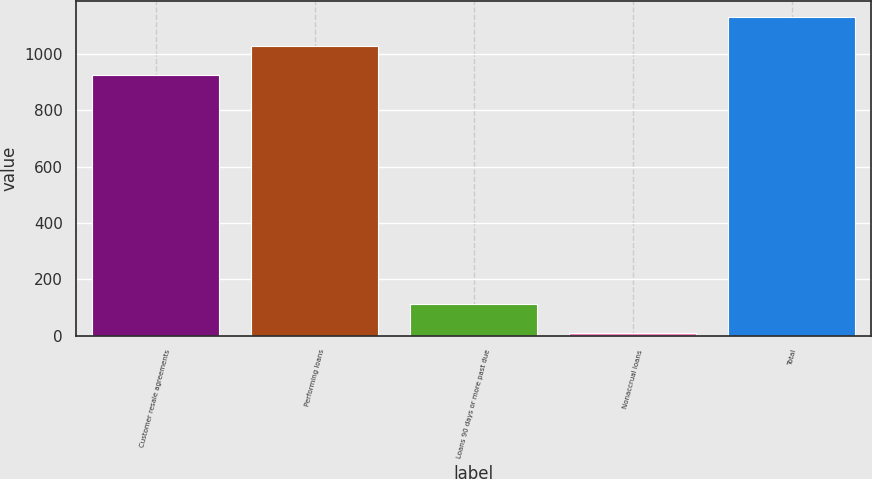<chart> <loc_0><loc_0><loc_500><loc_500><bar_chart><fcel>Customer resale agreements<fcel>Performing loans<fcel>Loans 90 days or more past due<fcel>Nonaccrual loans<fcel>Total<nl><fcel>925<fcel>1027.7<fcel>111.7<fcel>9<fcel>1130.4<nl></chart> 